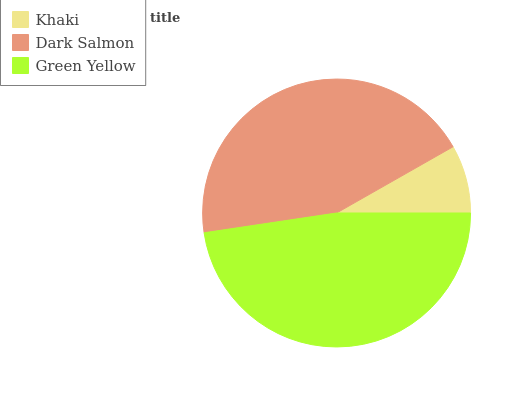Is Khaki the minimum?
Answer yes or no. Yes. Is Green Yellow the maximum?
Answer yes or no. Yes. Is Dark Salmon the minimum?
Answer yes or no. No. Is Dark Salmon the maximum?
Answer yes or no. No. Is Dark Salmon greater than Khaki?
Answer yes or no. Yes. Is Khaki less than Dark Salmon?
Answer yes or no. Yes. Is Khaki greater than Dark Salmon?
Answer yes or no. No. Is Dark Salmon less than Khaki?
Answer yes or no. No. Is Dark Salmon the high median?
Answer yes or no. Yes. Is Dark Salmon the low median?
Answer yes or no. Yes. Is Khaki the high median?
Answer yes or no. No. Is Green Yellow the low median?
Answer yes or no. No. 